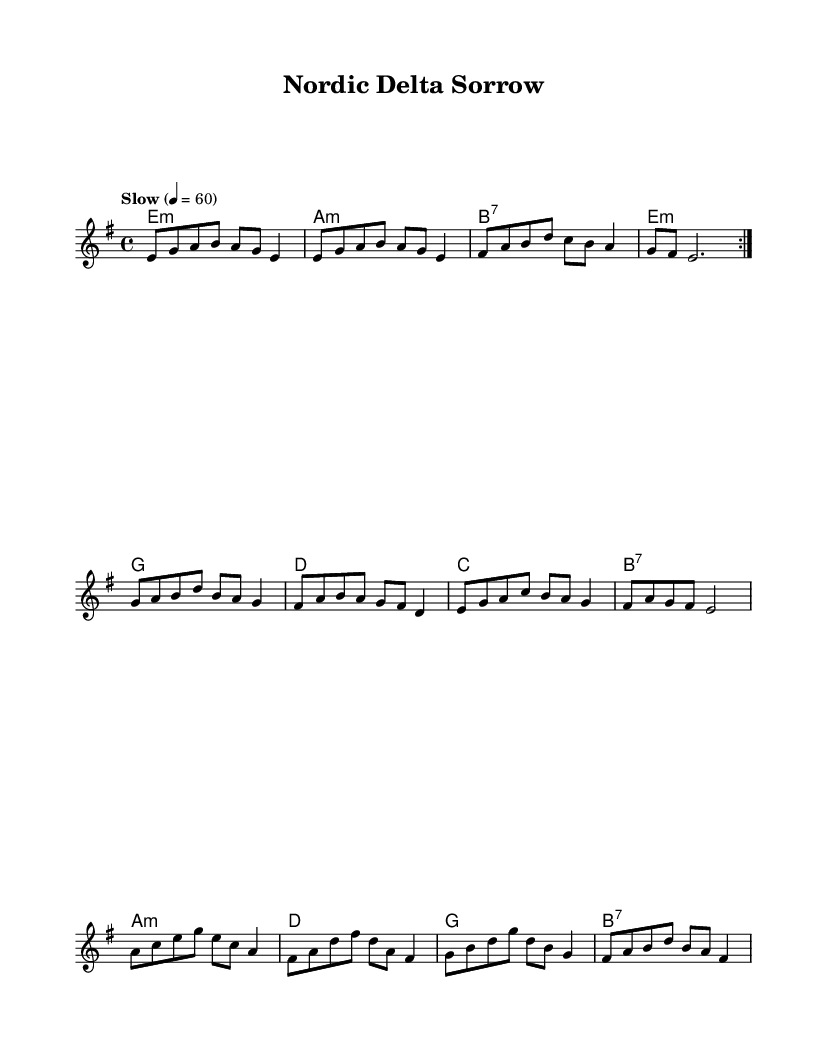What is the key signature of this music? The key signature indicated by the key signature at the beginning of the music shows that it is in E minor, which has one sharp (F#) in the key signature.
Answer: E minor What is the time signature of this music? The time signature is shown at the beginning of the piece as "4/4", which indicates that there are four beats in each measure and the quarter note gets one beat.
Answer: 4/4 What is the tempo marking of this piece? The tempo marking is written in the score as "Slow" with a metronome marking of 60 beats per minute, indicating a slow pace for the performance.
Answer: Slow How many measures are there in the melody? By counting the measures in the melody section, there are a total of 12 measures present in the melody part before the repeat.
Answer: 12 Which chord appears most frequently in the harmonies? Upon examining the harmonies, it can be seen that the E minor chord appears multiple times throughout the progression, indicating its frequent use in the piece.
Answer: E minor Does this piece include a seventh chord, and if so, which one? Yes, the score includes a seventh chord, specifically a B7 chord, as indicated in the harmony section.
Answer: B7 What overall mood or theme does this Blues piece convey? The piece is characterized by themes of loneliness and struggle, which are common in Delta Blues music, as reflected in its melodic choices and harmonic progressions.
Answer: Loneliness and struggle 